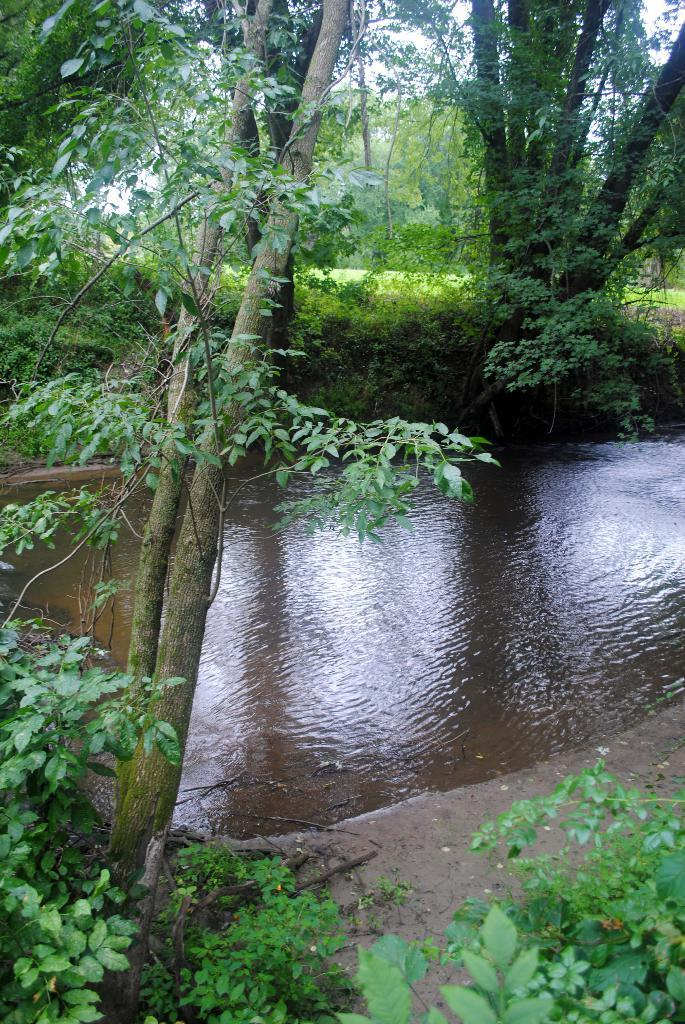What type of natural elements can be seen in the image? There are many trees and plants in the image. What is located in the middle of the image? There is water in the middle of the image. What part of the natural environment is visible in the background of the image? The sky is visible in the background of the image. What type of protest is taking place in the image? There is no protest present in the image; it features natural elements such as trees, plants, water, and the sky. Can you see a snail climbing up one of the trees in the image? There is no snail visible in the image; it only features trees, plants, water, and the sky. 